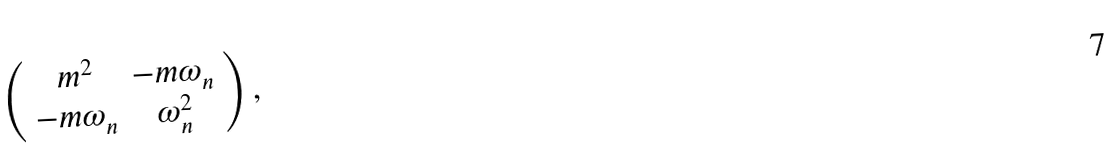Convert formula to latex. <formula><loc_0><loc_0><loc_500><loc_500>\left ( \begin{array} { c c } m ^ { 2 } & - m \omega _ { n } \\ - m \omega _ { n } & \omega ^ { 2 } _ { n } \end{array} \right ) ,</formula> 